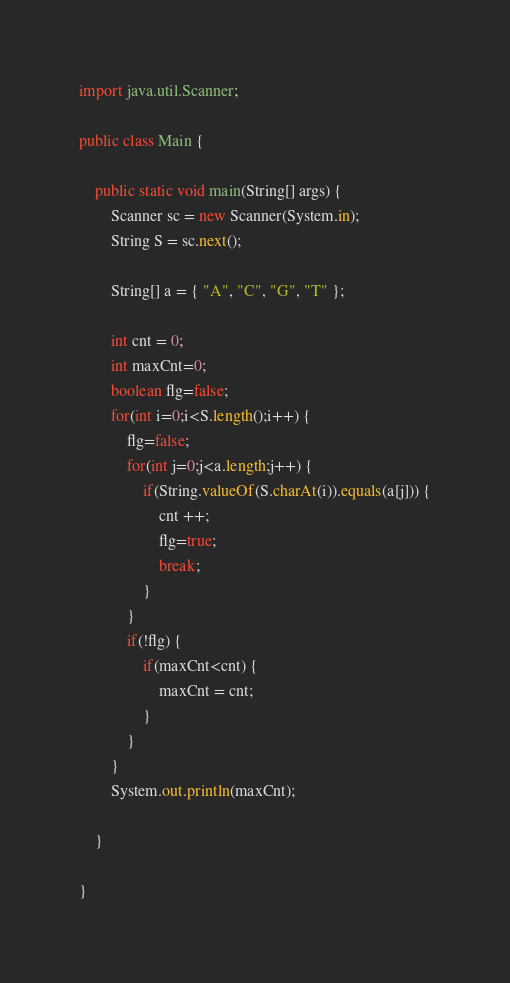<code> <loc_0><loc_0><loc_500><loc_500><_Java_>import java.util.Scanner;

public class Main {

	public static void main(String[] args) {
		Scanner sc = new Scanner(System.in);
		String S = sc.next();

		String[] a = { "A", "C", "G", "T" };

		int cnt = 0;
		int maxCnt=0;
		boolean flg=false;
		for(int i=0;i<S.length();i++) {
			flg=false;
			for(int j=0;j<a.length;j++) {
				if(String.valueOf(S.charAt(i)).equals(a[j])) {
					cnt ++;
					flg=true;
					break;
				}
			}
			if(!flg) {
				if(maxCnt<cnt) {
					maxCnt = cnt;
				}
			}
		}
		System.out.println(maxCnt);

	}

}
</code> 